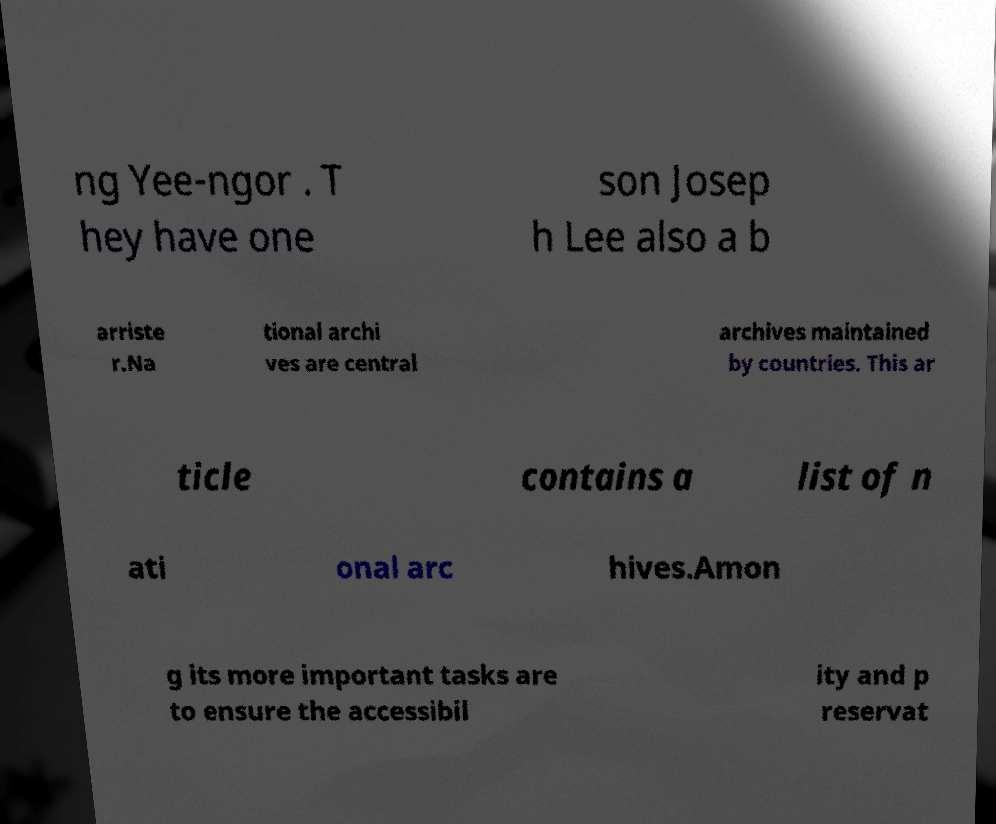For documentation purposes, I need the text within this image transcribed. Could you provide that? ng Yee-ngor . T hey have one son Josep h Lee also a b arriste r.Na tional archi ves are central archives maintained by countries. This ar ticle contains a list of n ati onal arc hives.Amon g its more important tasks are to ensure the accessibil ity and p reservat 